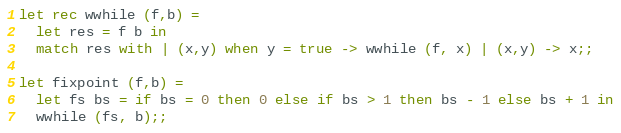Convert code to text. <code><loc_0><loc_0><loc_500><loc_500><_OCaml_>
let rec wwhile (f,b) =
  let res = f b in
  match res with | (x,y) when y = true -> wwhile (f, x) | (x,y) -> x;;

let fixpoint (f,b) =
  let fs bs = if bs = 0 then 0 else if bs > 1 then bs - 1 else bs + 1 in
  wwhile (fs, b);;
</code> 